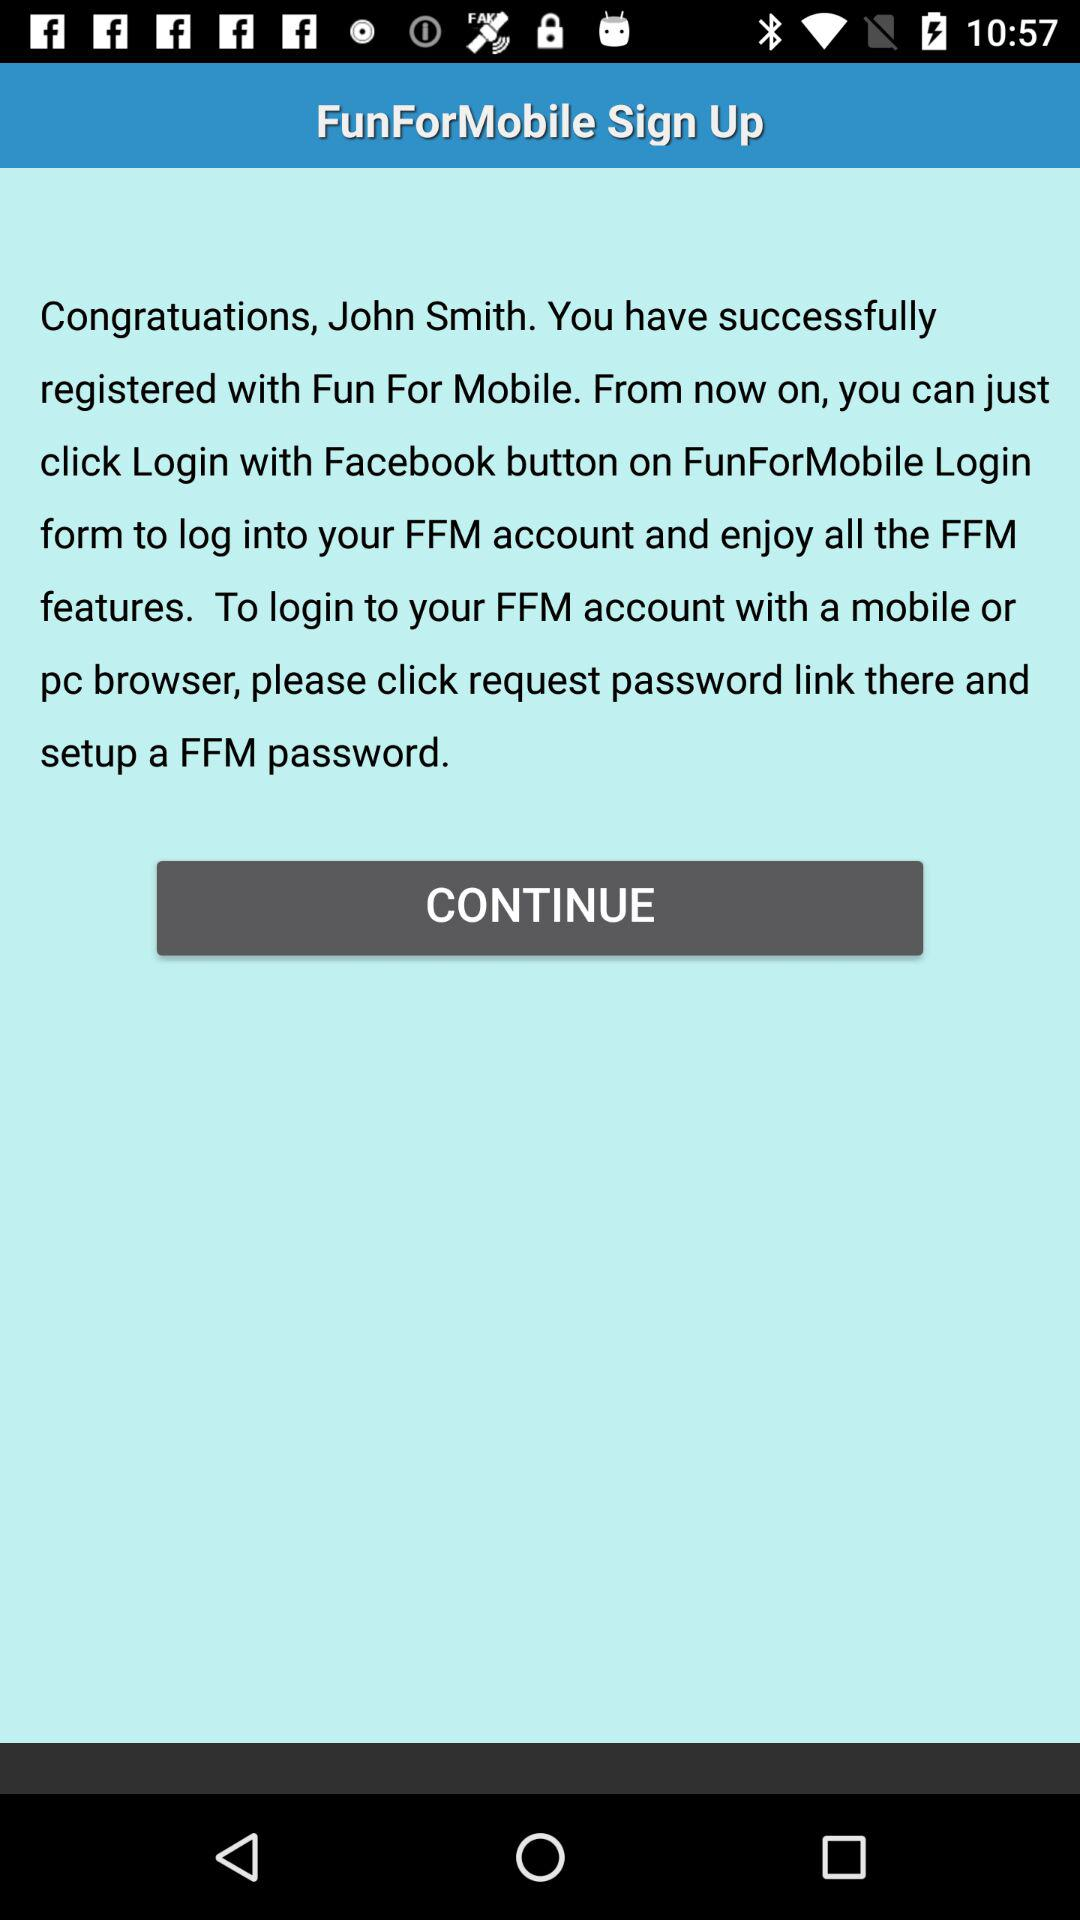What is the name of the application? The name of the application is "FunForMobile". 